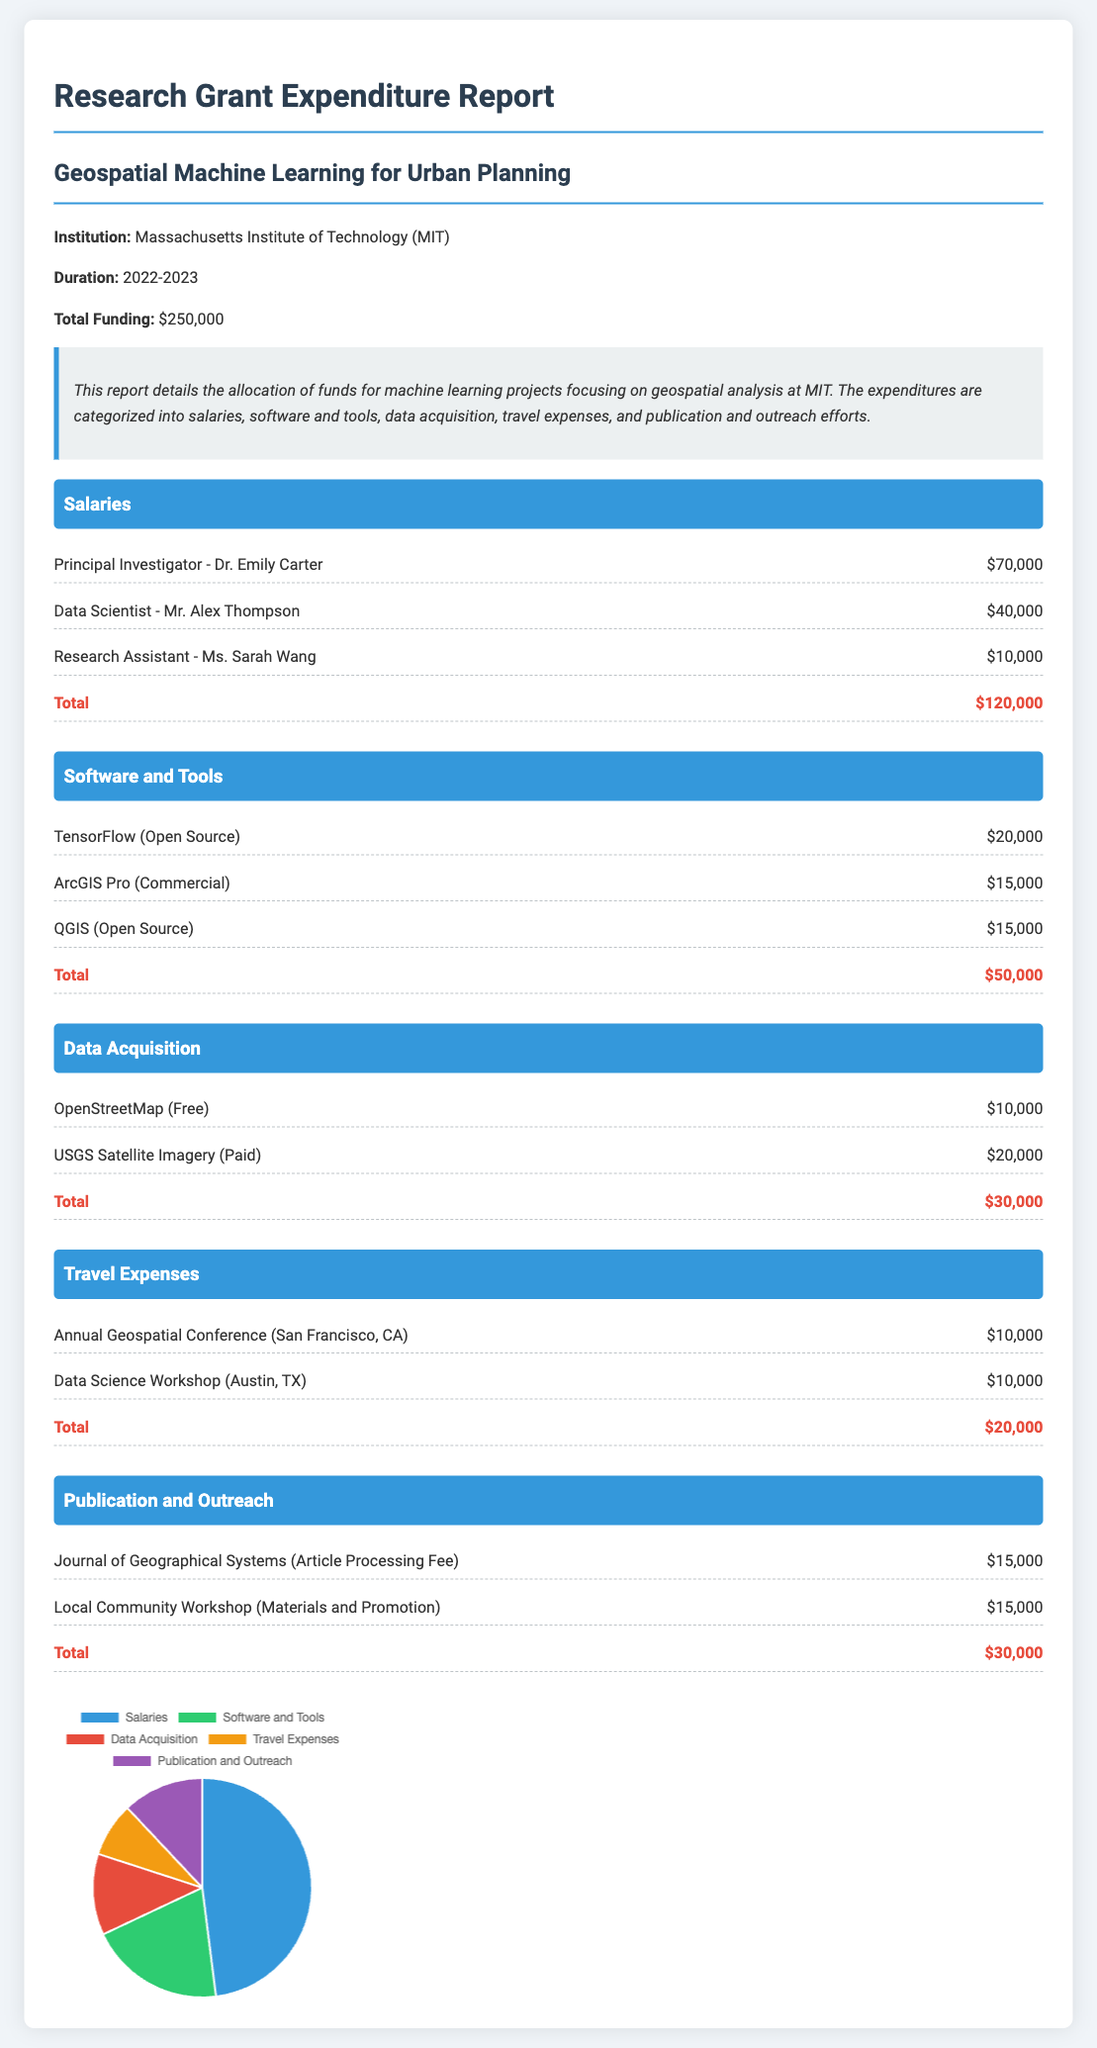What is the title of the project? The title of the project is stated in the document as "Geospatial Machine Learning for Urban Planning."
Answer: Geospatial Machine Learning for Urban Planning What is the total funding amount? The total funding amount is explicitly listed in the document, which shows a total of $250,000.
Answer: $250,000 Who is the Principal Investigator? The document specifies the Principal Investigator as Dr. Emily Carter.
Answer: Dr. Emily Carter How much was allocated for Data Acquisition? The total allocated for Data Acquisition is calculated in the document, which totals $30,000.
Answer: $30,000 What percentage of the total funding was spent on Salaries? Salaries amount to $120,000 and the percentage is computed based on the total funding of $250,000, which is 48%.
Answer: 48% What are the total travel expenses? The total travel expenses listed in the document amount to $20,000, which is clearly stated.
Answer: $20,000 What software had the highest expenditure? The document indicates that TensorFlow had the highest expenditure among software, costing $20,000.
Answer: TensorFlow What is included in the Publication and Outreach category? The category includes costs for publication fees and community workshop expenses, totaling $30,000.
Answer: Journal of Geographical Systems, Local Community Workshop How many items are listed under Software and Tools? The document outlines three items listed under Software and Tools.
Answer: Three 